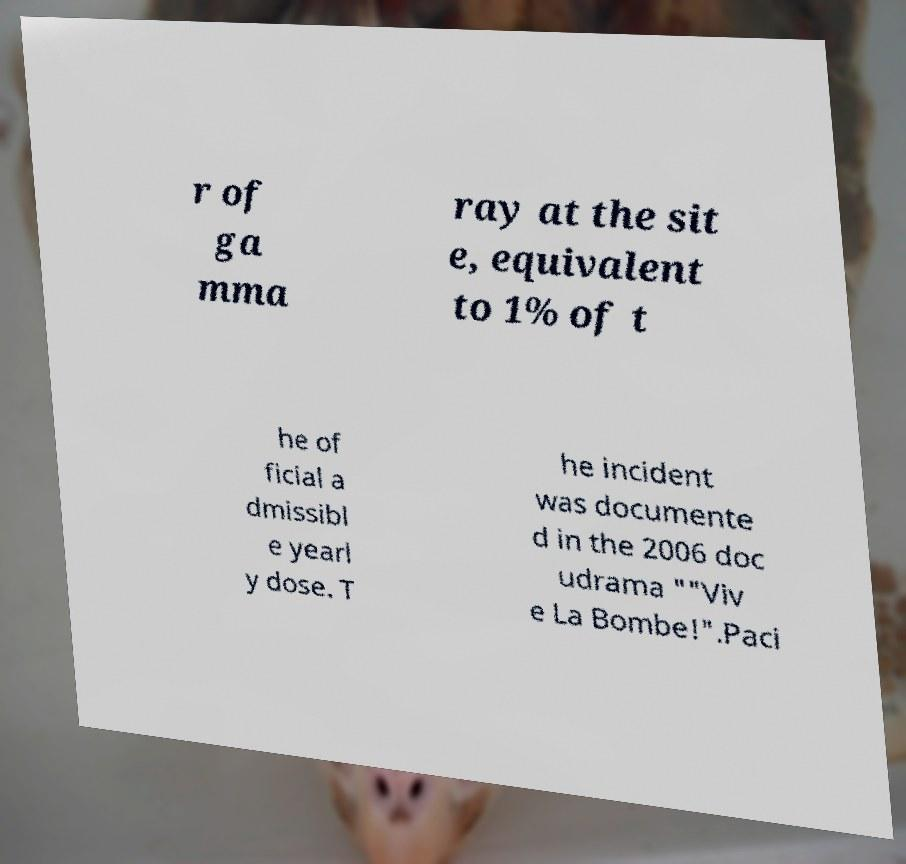Please identify and transcribe the text found in this image. r of ga mma ray at the sit e, equivalent to 1% of t he of ficial a dmissibl e yearl y dose. T he incident was documente d in the 2006 doc udrama ""Viv e La Bombe!".Paci 